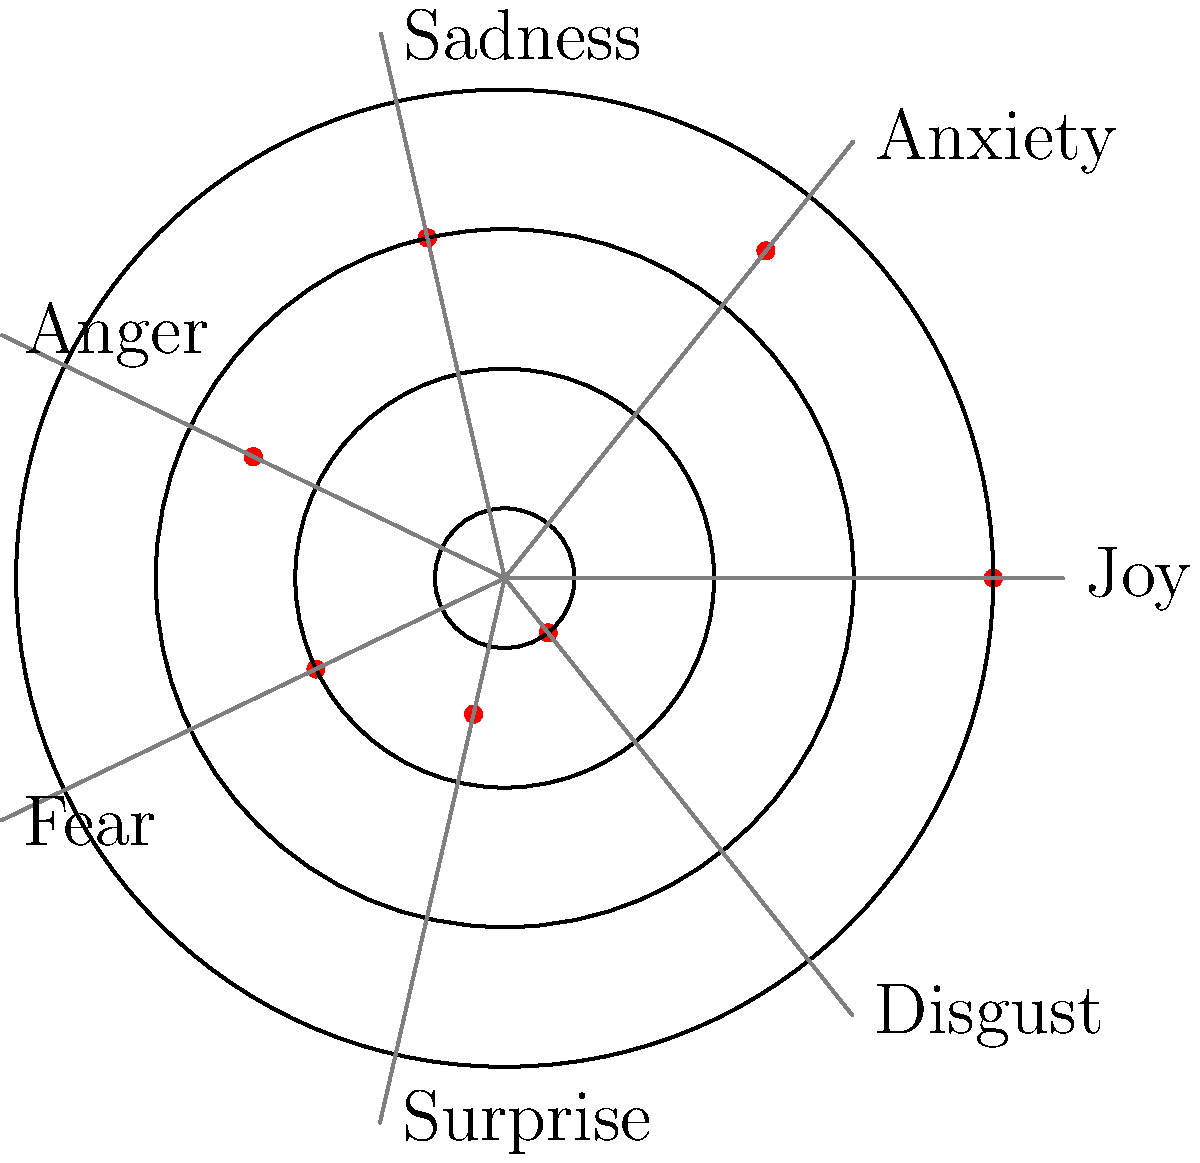In the polar graph above, emotional states are plotted to visualize mood fluctuations over time. Each emotion is represented by a point on the graph, where the distance from the center indicates the intensity of the emotion. Based on this visualization, which emotion appears to be experienced most intensely by the patient? To determine which emotion is experienced most intensely, we need to follow these steps:

1. Understand the graph: 
   - The polar graph represents different emotions at various angles.
   - The distance from the center (radius) represents the intensity of the emotion.

2. Identify the emotions and their positions:
   - Joy: located at 0 degrees
   - Anxiety: located at about 51.4 degrees
   - Sadness: located at about 102.8 degrees
   - Anger: located at about 154.2 degrees
   - Fear: located at about 205.7 degrees
   - Surprise: located at about 257.1 degrees
   - Disgust: located at about 308.5 degrees

3. Compare the radial distances:
   - Joy has the largest radial distance from the center.
   - It is plotted on the outermost circle (radius = 7).
   - All other emotions are plotted closer to the center.

4. Interpret the results:
   - The emotion with the largest radial distance is experienced most intensely.
   - In this case, Joy is plotted farthest from the center.

Therefore, based on this polar graph visualization, Joy appears to be the emotion experienced most intensely by the patient.
Answer: Joy 